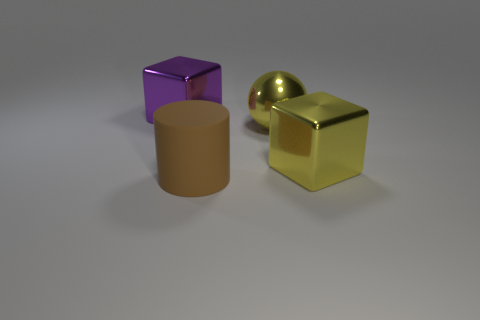Is the number of brown objects greater than the number of gray cubes?
Make the answer very short. Yes. The cube that is on the left side of the object in front of the metal block in front of the large purple block is made of what material?
Offer a very short reply. Metal. Do the ball and the big matte thing have the same color?
Give a very brief answer. No. Are there any big shiny spheres that have the same color as the big matte object?
Make the answer very short. No. The purple metal object that is the same size as the matte thing is what shape?
Your answer should be compact. Cube. Are there fewer brown cubes than cubes?
Give a very brief answer. Yes. How many brown cylinders are the same size as the purple block?
Offer a very short reply. 1. There is a metal thing that is the same color as the big metallic ball; what shape is it?
Keep it short and to the point. Cube. What material is the purple cube?
Provide a short and direct response. Metal. What is the size of the shiny object that is to the left of the big matte cylinder?
Keep it short and to the point. Large. 